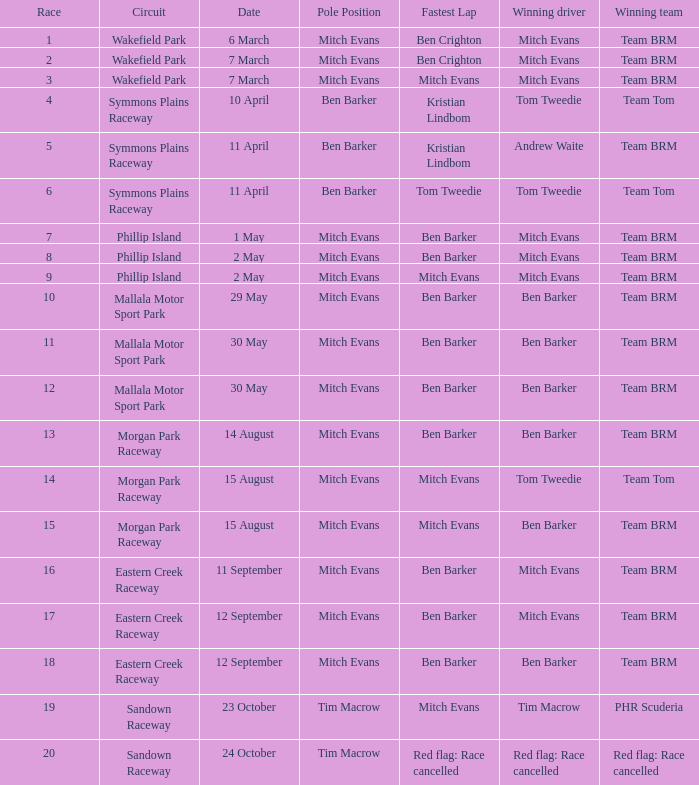What team won Race 17? Team BRM. 